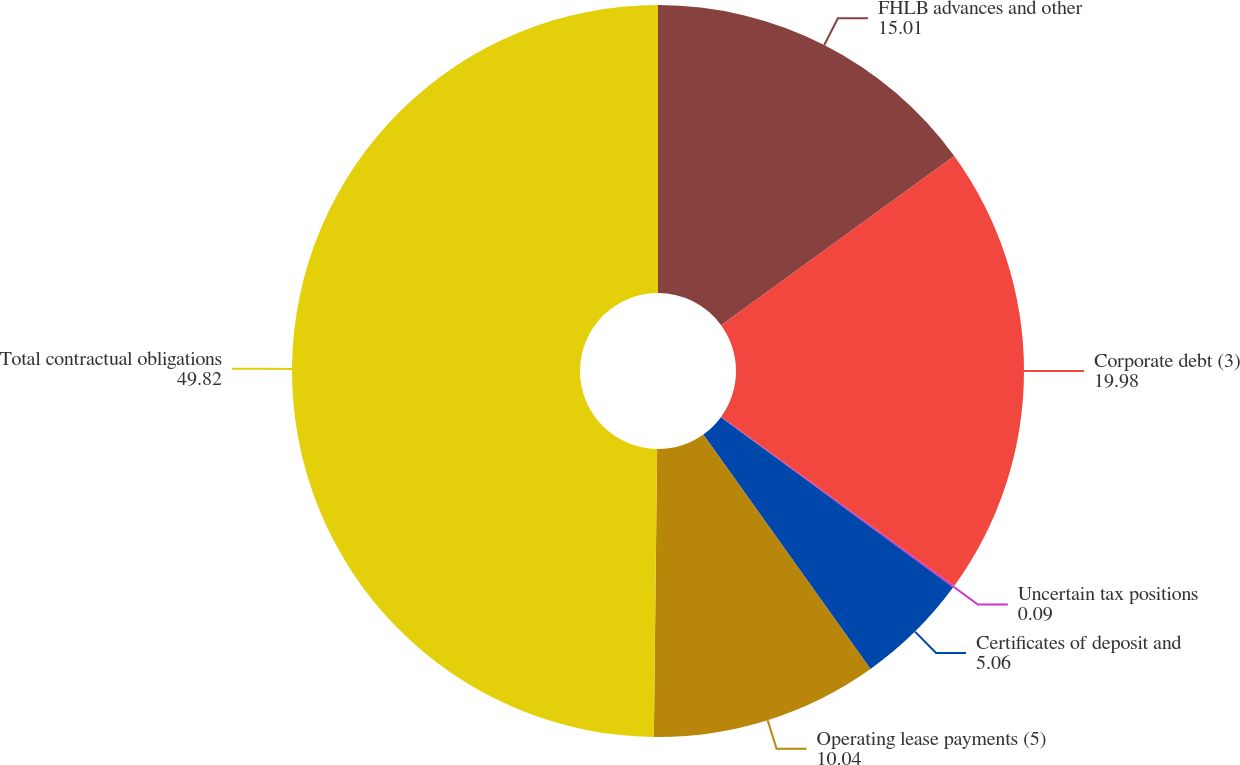Convert chart to OTSL. <chart><loc_0><loc_0><loc_500><loc_500><pie_chart><fcel>FHLB advances and other<fcel>Corporate debt (3)<fcel>Uncertain tax positions<fcel>Certificates of deposit and<fcel>Operating lease payments (5)<fcel>Total contractual obligations<nl><fcel>15.01%<fcel>19.98%<fcel>0.09%<fcel>5.06%<fcel>10.04%<fcel>49.82%<nl></chart> 